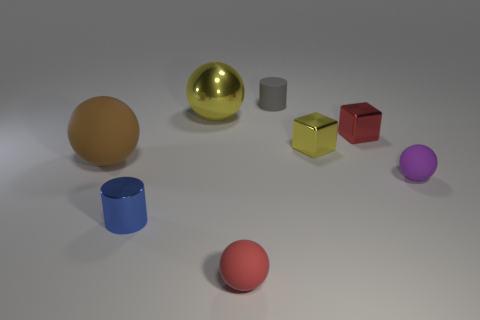There is a tiny gray matte object; are there any small gray matte things on the right side of it?
Give a very brief answer. No. What size is the rubber ball that is left of the small red shiny thing and to the right of the small blue shiny thing?
Ensure brevity in your answer.  Small. What number of objects are small metallic cylinders or big shiny spheres?
Provide a succinct answer. 2. Does the red cube have the same size as the object left of the blue cylinder?
Your answer should be very brief. No. There is a yellow metal object to the right of the gray cylinder that is on the right side of the tiny object that is in front of the tiny blue metallic thing; what size is it?
Your answer should be compact. Small. Are there any large brown matte balls?
Make the answer very short. Yes. There is another object that is the same color as the big metal thing; what material is it?
Make the answer very short. Metal. What number of other spheres are the same color as the metal sphere?
Make the answer very short. 0. How many objects are cylinders that are right of the red matte sphere or tiny rubber things behind the large yellow ball?
Your response must be concise. 1. There is a object behind the big yellow shiny sphere; what number of objects are in front of it?
Provide a short and direct response. 7. 